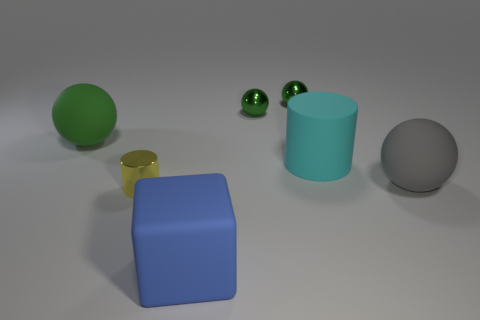What can you infer about the lighting in this scene? The scene has soft, diffused lighting, likely from a source above the objects, as indicated by the gentle shadows cast directly underneath each object. There is no harsh glare, and the overall illumination is even, suggesting an indoor setup with controlled lighting conditions. Does the lighting affect the colors of the objects? Yes, the lighting can influence the perception of color. Soft lighting helps to maintain the true colors of the objects, as there's less contrast and saturation variation than you would see in more dramatic lighting conditions. 